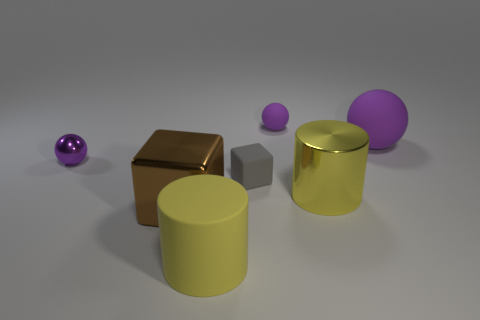Add 3 yellow metal things. How many objects exist? 10 Subtract all cylinders. How many objects are left? 5 Subtract all small gray things. Subtract all large brown metallic things. How many objects are left? 5 Add 4 large matte balls. How many large matte balls are left? 5 Add 3 big brown shiny blocks. How many big brown shiny blocks exist? 4 Subtract 0 cyan balls. How many objects are left? 7 